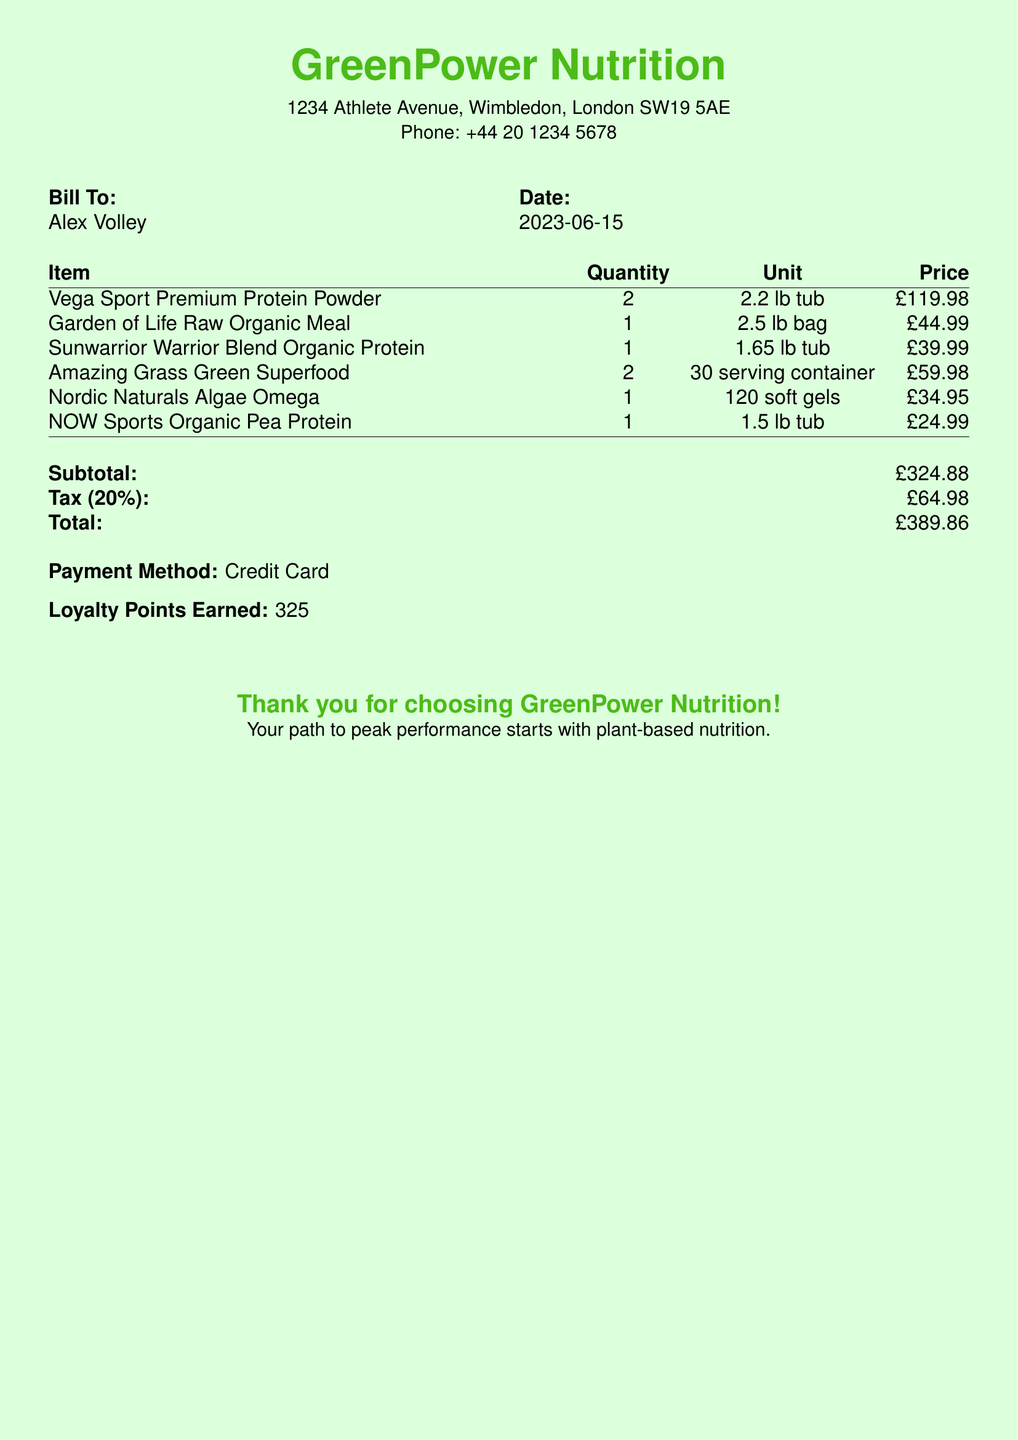What is the date of the bill? The date of the bill is specified in the "Date" section, which is 2023-06-15.
Answer: 2023-06-15 Who is the bill addressed to? The bill lists "Bill To" as Alex Volley.
Answer: Alex Volley What is the total amount? The "Total" section shows the total amount due as £389.86.
Answer: £389.86 How many loyalty points were earned? The bill mentions that "Loyalty Points Earned" are 325.
Answer: 325 What is the quantity of the Vega Sport Premium Protein Powder purchased? The "Quantity" column shows that 2 tubs of this protein powder were purchased.
Answer: 2 What is the subtotal amount before tax? The subtotal is listed as £324.88 in the document.
Answer: £324.88 How many servings does the Amazing Grass Green Superfood container have? The document states that it has 30 servings in the container.
Answer: 30 servings What method of payment was used? The payment method is specified as Credit Card in the document.
Answer: Credit Card What is the price of the Garden of Life Raw Organic Meal? The price listed for this item is £44.99.
Answer: £44.99 